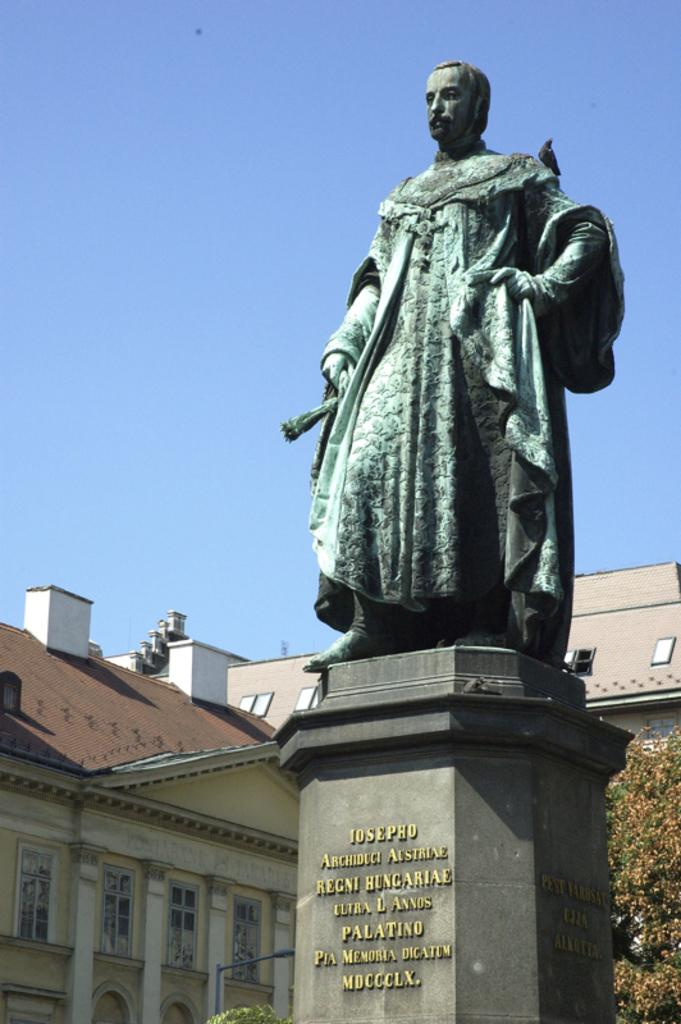What type of structures can be seen in the image? There are buildings in the image. What feature is visible on the buildings? There are windows visible in the image. What type of vegetation is present in the image? There are trees in the image. What part of the natural environment is visible in the image? The sky is visible in the image. What additional object can be seen in the image? There is a statue in the image. What is on top of the statue? There is a bird on the statue. Can you tell me who won the argument between the shoes and the bite in the image? There is no argument, shoes, or bite present in the image. 